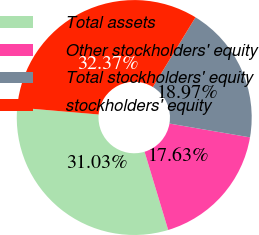Convert chart. <chart><loc_0><loc_0><loc_500><loc_500><pie_chart><fcel>Total assets<fcel>Other stockholders' equity<fcel>Total stockholders' equity<fcel>stockholders' equity<nl><fcel>31.03%<fcel>17.63%<fcel>18.97%<fcel>32.37%<nl></chart> 